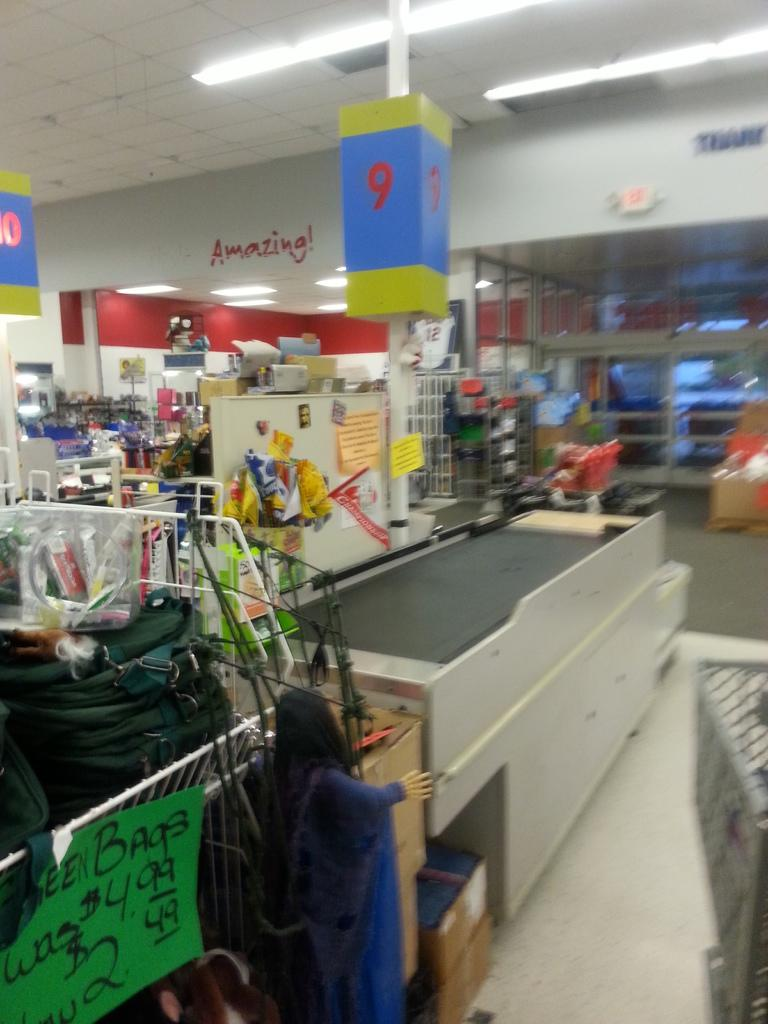What type of location is shown in the image? The image depicts an inside view of a mall. What objects can be seen in the image that are commonly used for carrying items? There are carts in the image. What type of advertisements or promotional materials can be seen in the image? There are hoardings in the image. What provides illumination in the image? There are lights in the image. What type of branch can be seen growing from the ceiling in the image? There is no branch growing from the ceiling in the image; it depicts an indoor mall setting. 